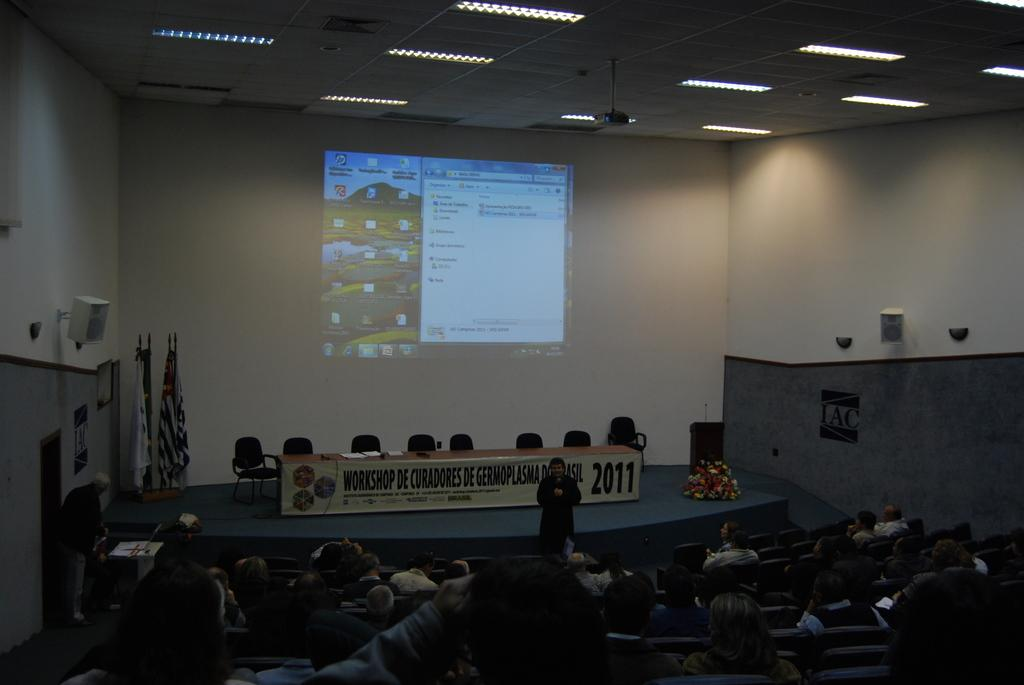What are the people in the image doing? The people in the image are sitting on chairs. What is on the table in the image? There are papers and other objects on the table. What can be seen in the image that represents a country or organization? There are flags in the image. What type of decoration is present in the image? There are flowers in the image. What device is visible in the image for displaying information? There is a screen in the image. What is used for amplifying sound in the image? There are speakers in the image. What type of structure is present in the background of the image? There is a wall in the image. How many ants can be seen crawling on the table in the image? There are no ants present in the image. What team is represented by the flags in the image? The flags in the image do not represent any specific team; they represent countries or organizations. 